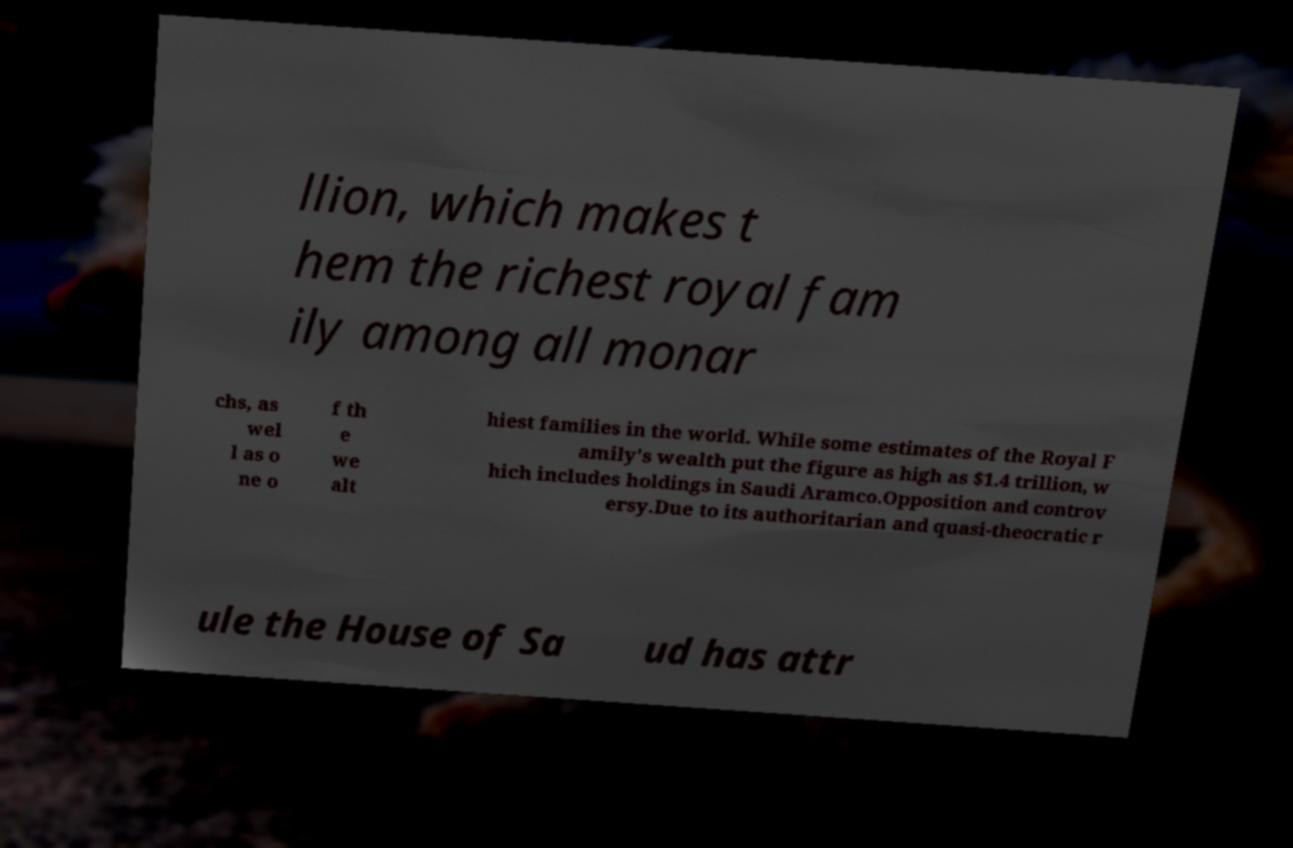I need the written content from this picture converted into text. Can you do that? llion, which makes t hem the richest royal fam ily among all monar chs, as wel l as o ne o f th e we alt hiest families in the world. While some estimates of the Royal F amily's wealth put the figure as high as $1.4 trillion, w hich includes holdings in Saudi Aramco.Opposition and controv ersy.Due to its authoritarian and quasi-theocratic r ule the House of Sa ud has attr 